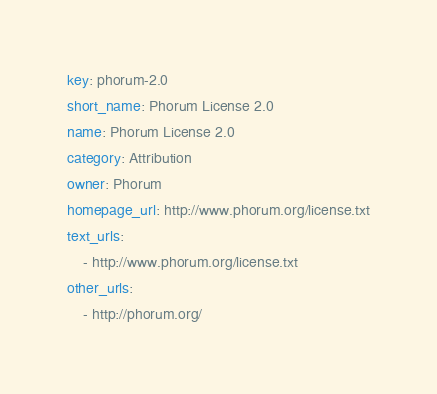Convert code to text. <code><loc_0><loc_0><loc_500><loc_500><_YAML_>key: phorum-2.0
short_name: Phorum License 2.0
name: Phorum License 2.0
category: Attribution
owner: Phorum
homepage_url: http://www.phorum.org/license.txt
text_urls:
    - http://www.phorum.org/license.txt
other_urls:
    - http://phorum.org/
</code> 